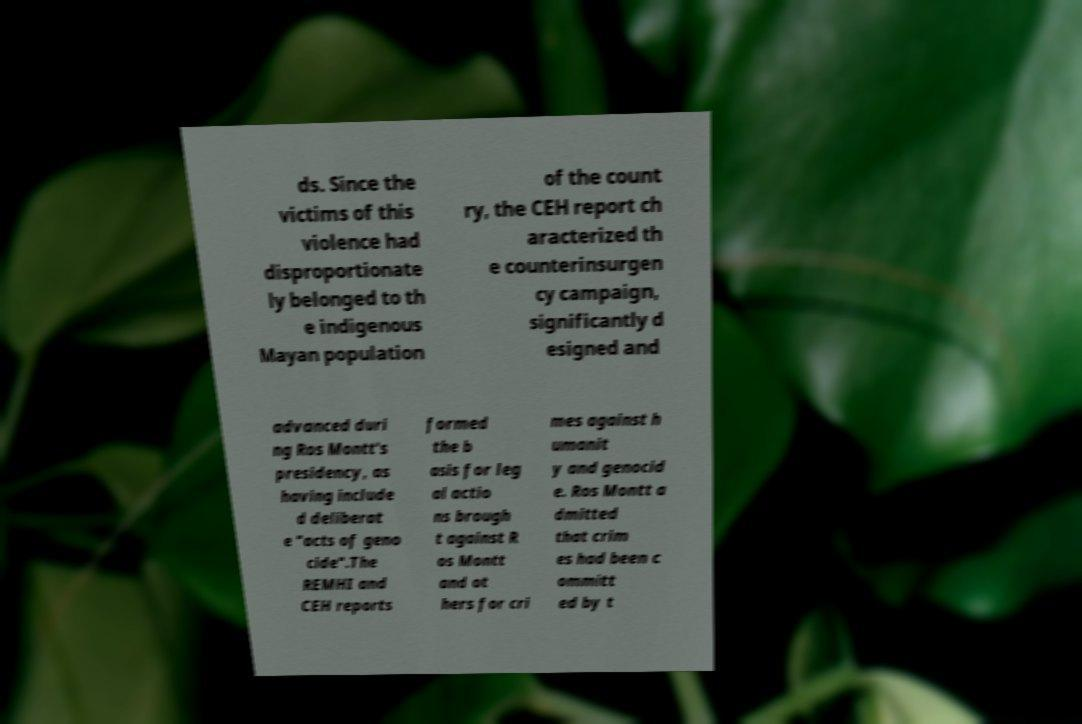What messages or text are displayed in this image? I need them in a readable, typed format. ds. Since the victims of this violence had disproportionate ly belonged to th e indigenous Mayan population of the count ry, the CEH report ch aracterized th e counterinsurgen cy campaign, significantly d esigned and advanced duri ng Ros Montt's presidency, as having include d deliberat e "acts of geno cide".The REMHI and CEH reports formed the b asis for leg al actio ns brough t against R os Montt and ot hers for cri mes against h umanit y and genocid e. Ros Montt a dmitted that crim es had been c ommitt ed by t 